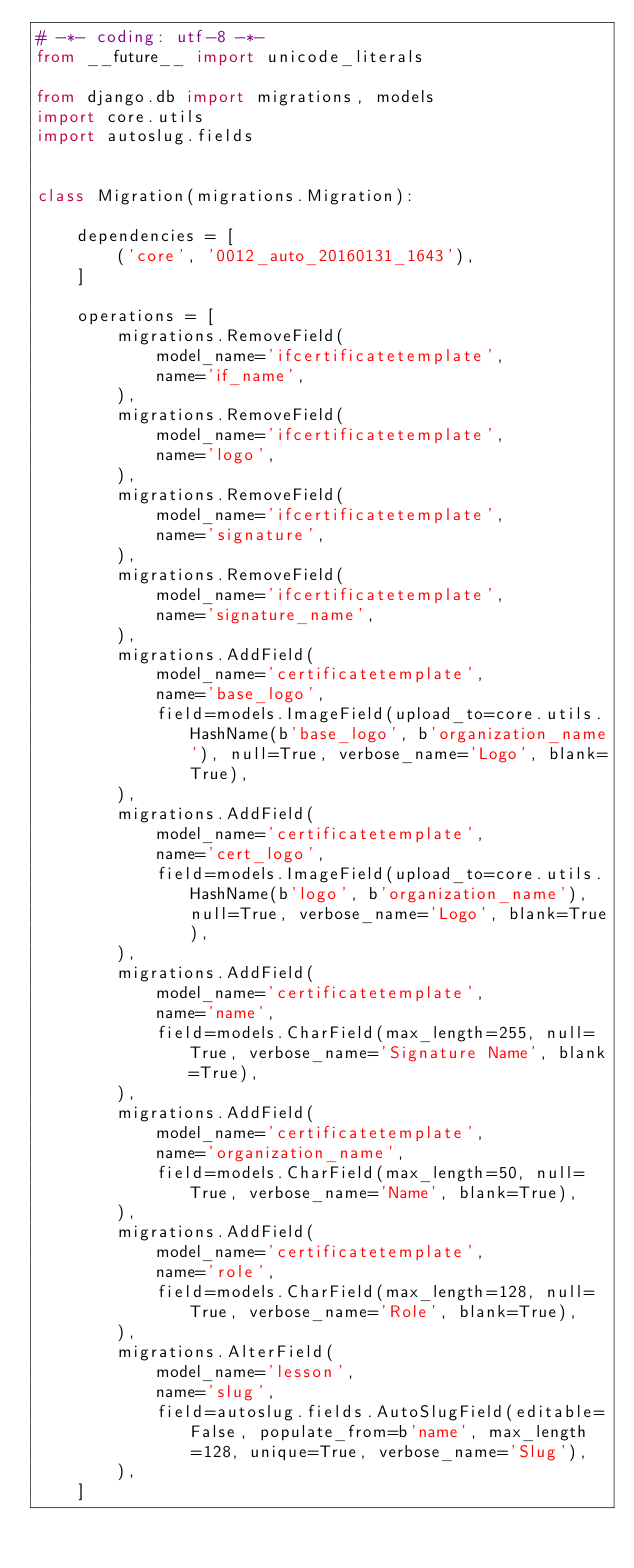<code> <loc_0><loc_0><loc_500><loc_500><_Python_># -*- coding: utf-8 -*-
from __future__ import unicode_literals

from django.db import migrations, models
import core.utils
import autoslug.fields


class Migration(migrations.Migration):

    dependencies = [
        ('core', '0012_auto_20160131_1643'),
    ]

    operations = [
        migrations.RemoveField(
            model_name='ifcertificatetemplate',
            name='if_name',
        ),
        migrations.RemoveField(
            model_name='ifcertificatetemplate',
            name='logo',
        ),
        migrations.RemoveField(
            model_name='ifcertificatetemplate',
            name='signature',
        ),
        migrations.RemoveField(
            model_name='ifcertificatetemplate',
            name='signature_name',
        ),
        migrations.AddField(
            model_name='certificatetemplate',
            name='base_logo',
            field=models.ImageField(upload_to=core.utils.HashName(b'base_logo', b'organization_name'), null=True, verbose_name='Logo', blank=True),
        ),
        migrations.AddField(
            model_name='certificatetemplate',
            name='cert_logo',
            field=models.ImageField(upload_to=core.utils.HashName(b'logo', b'organization_name'), null=True, verbose_name='Logo', blank=True),
        ),
        migrations.AddField(
            model_name='certificatetemplate',
            name='name',
            field=models.CharField(max_length=255, null=True, verbose_name='Signature Name', blank=True),
        ),
        migrations.AddField(
            model_name='certificatetemplate',
            name='organization_name',
            field=models.CharField(max_length=50, null=True, verbose_name='Name', blank=True),
        ),
        migrations.AddField(
            model_name='certificatetemplate',
            name='role',
            field=models.CharField(max_length=128, null=True, verbose_name='Role', blank=True),
        ),
        migrations.AlterField(
            model_name='lesson',
            name='slug',
            field=autoslug.fields.AutoSlugField(editable=False, populate_from=b'name', max_length=128, unique=True, verbose_name='Slug'),
        ),
    ]
</code> 